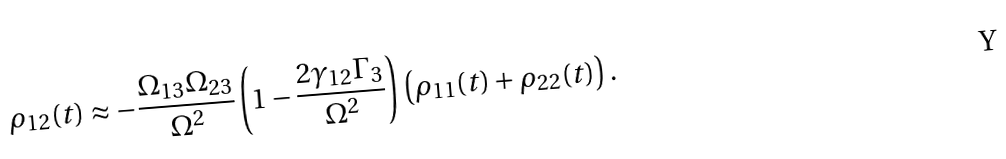Convert formula to latex. <formula><loc_0><loc_0><loc_500><loc_500>\rho _ { 1 2 } ( t ) \approx - \frac { \Omega _ { 1 3 } \Omega _ { 2 3 } } { \Omega ^ { 2 } } \left ( 1 - \frac { 2 \gamma _ { 1 2 } \Gamma _ { 3 } } { \Omega ^ { 2 } } \right ) \left ( \rho _ { 1 1 } ( t ) + \rho _ { 2 2 } ( t ) \right ) .</formula> 